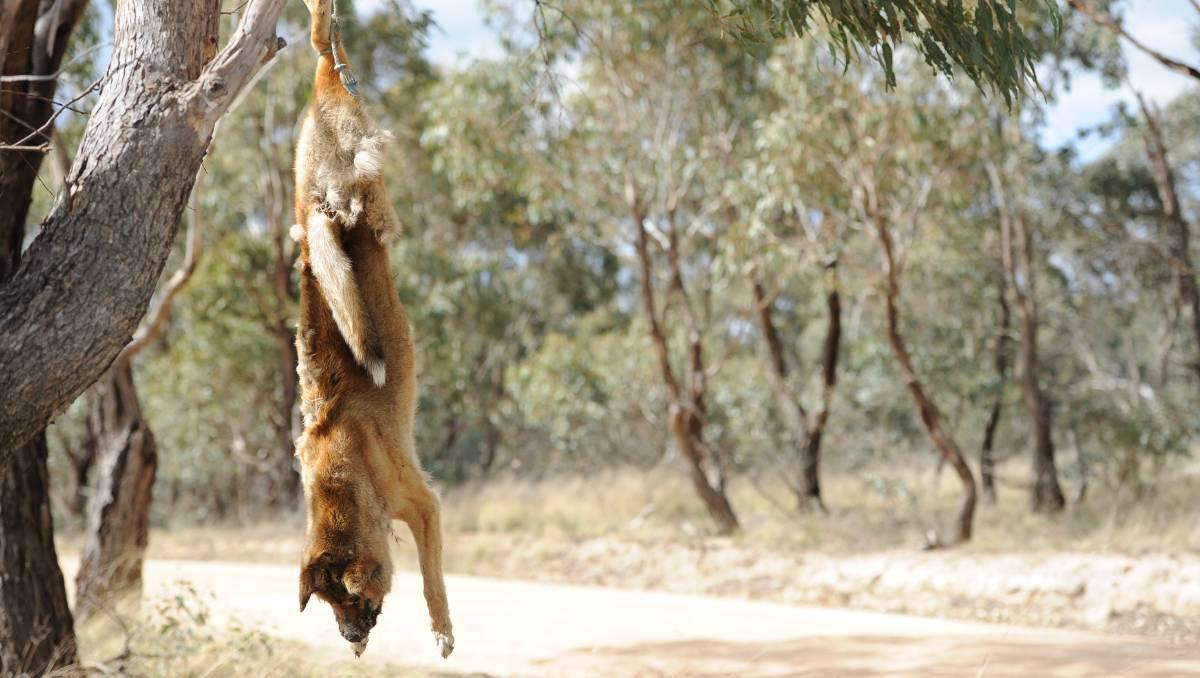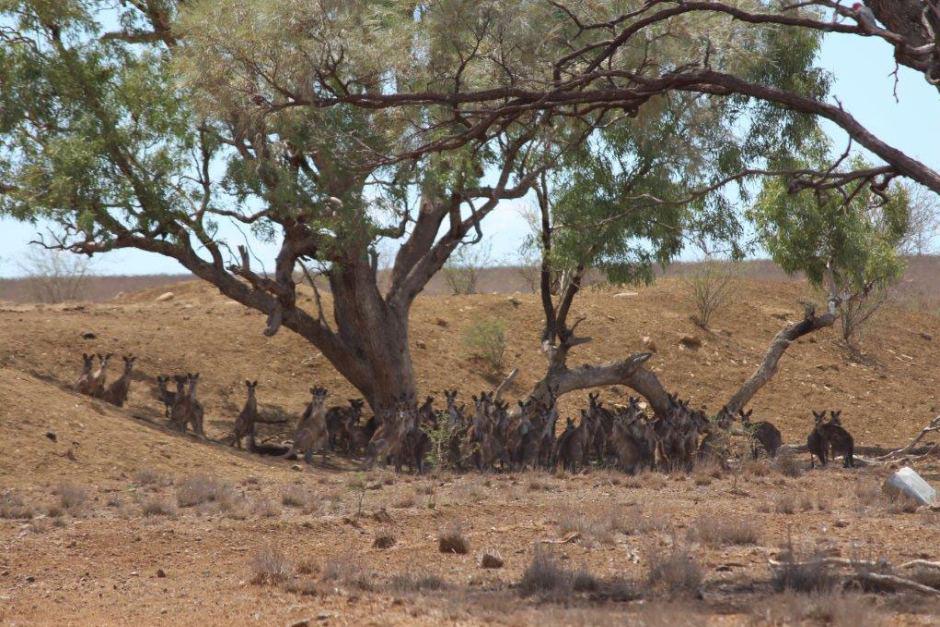The first image is the image on the left, the second image is the image on the right. Considering the images on both sides, is "There is one living animal in the image on the right." valid? Answer yes or no. No. The first image is the image on the left, the second image is the image on the right. Analyze the images presented: Is the assertion "An image shows one dingo standing on the ground." valid? Answer yes or no. No. 